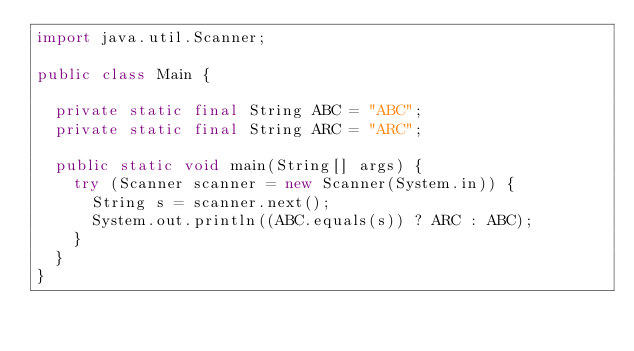<code> <loc_0><loc_0><loc_500><loc_500><_Java_>import java.util.Scanner;

public class Main {

	private static final String ABC = "ABC";
	private static final String ARC = "ARC";

	public static void main(String[] args) {
		try (Scanner scanner = new Scanner(System.in)) {
			String s = scanner.next();
			System.out.println((ABC.equals(s)) ? ARC : ABC);
		}
	}
}
</code> 